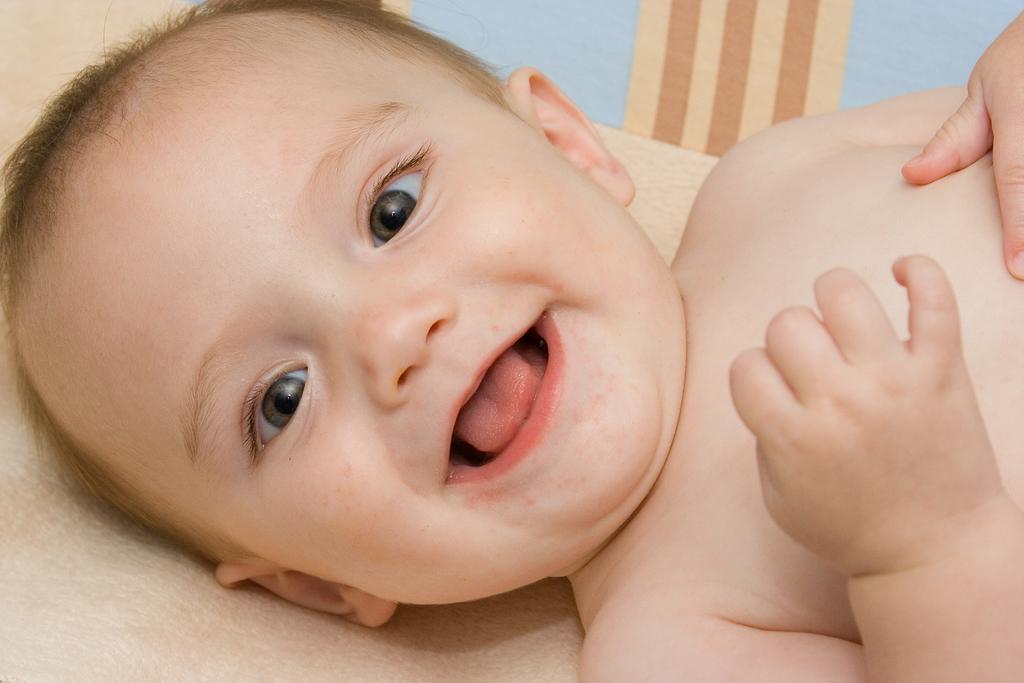How would you summarize this image in a sentence or two? In this picture we can see a child is lying and smiling, there is a cloth at the bottom. 